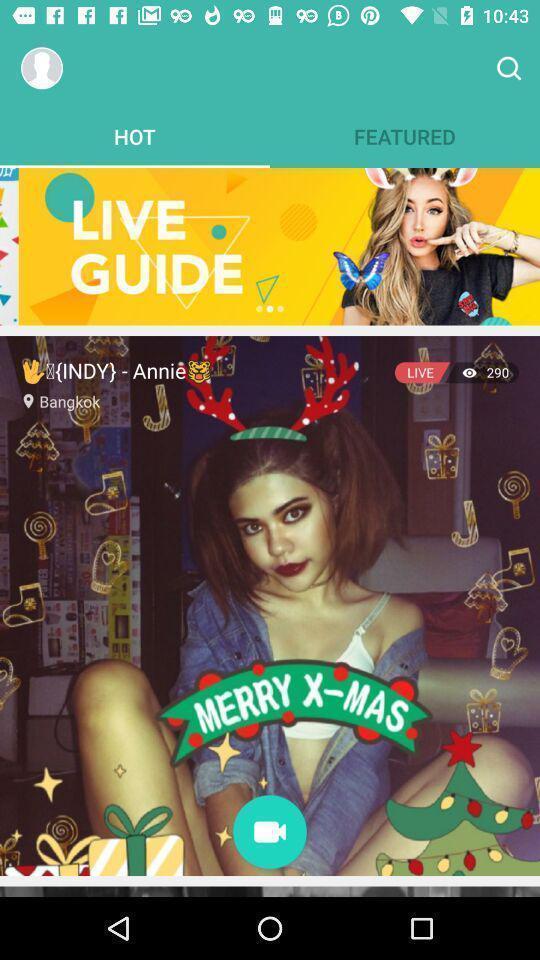Describe the content in this image. Page suggesting to make video call on a social app. 